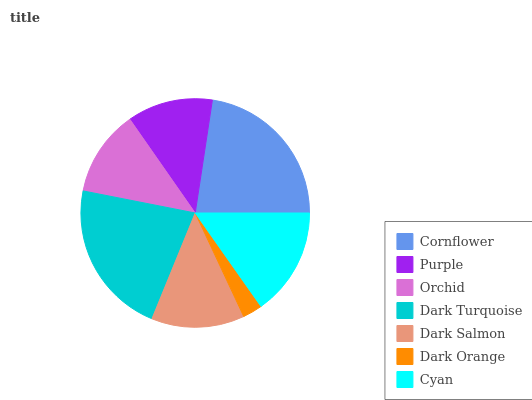Is Dark Orange the minimum?
Answer yes or no. Yes. Is Cornflower the maximum?
Answer yes or no. Yes. Is Purple the minimum?
Answer yes or no. No. Is Purple the maximum?
Answer yes or no. No. Is Cornflower greater than Purple?
Answer yes or no. Yes. Is Purple less than Cornflower?
Answer yes or no. Yes. Is Purple greater than Cornflower?
Answer yes or no. No. Is Cornflower less than Purple?
Answer yes or no. No. Is Dark Salmon the high median?
Answer yes or no. Yes. Is Dark Salmon the low median?
Answer yes or no. Yes. Is Orchid the high median?
Answer yes or no. No. Is Cornflower the low median?
Answer yes or no. No. 